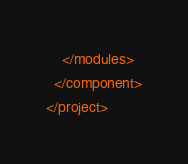<code> <loc_0><loc_0><loc_500><loc_500><_XML_>    </modules>
  </component>
</project></code> 